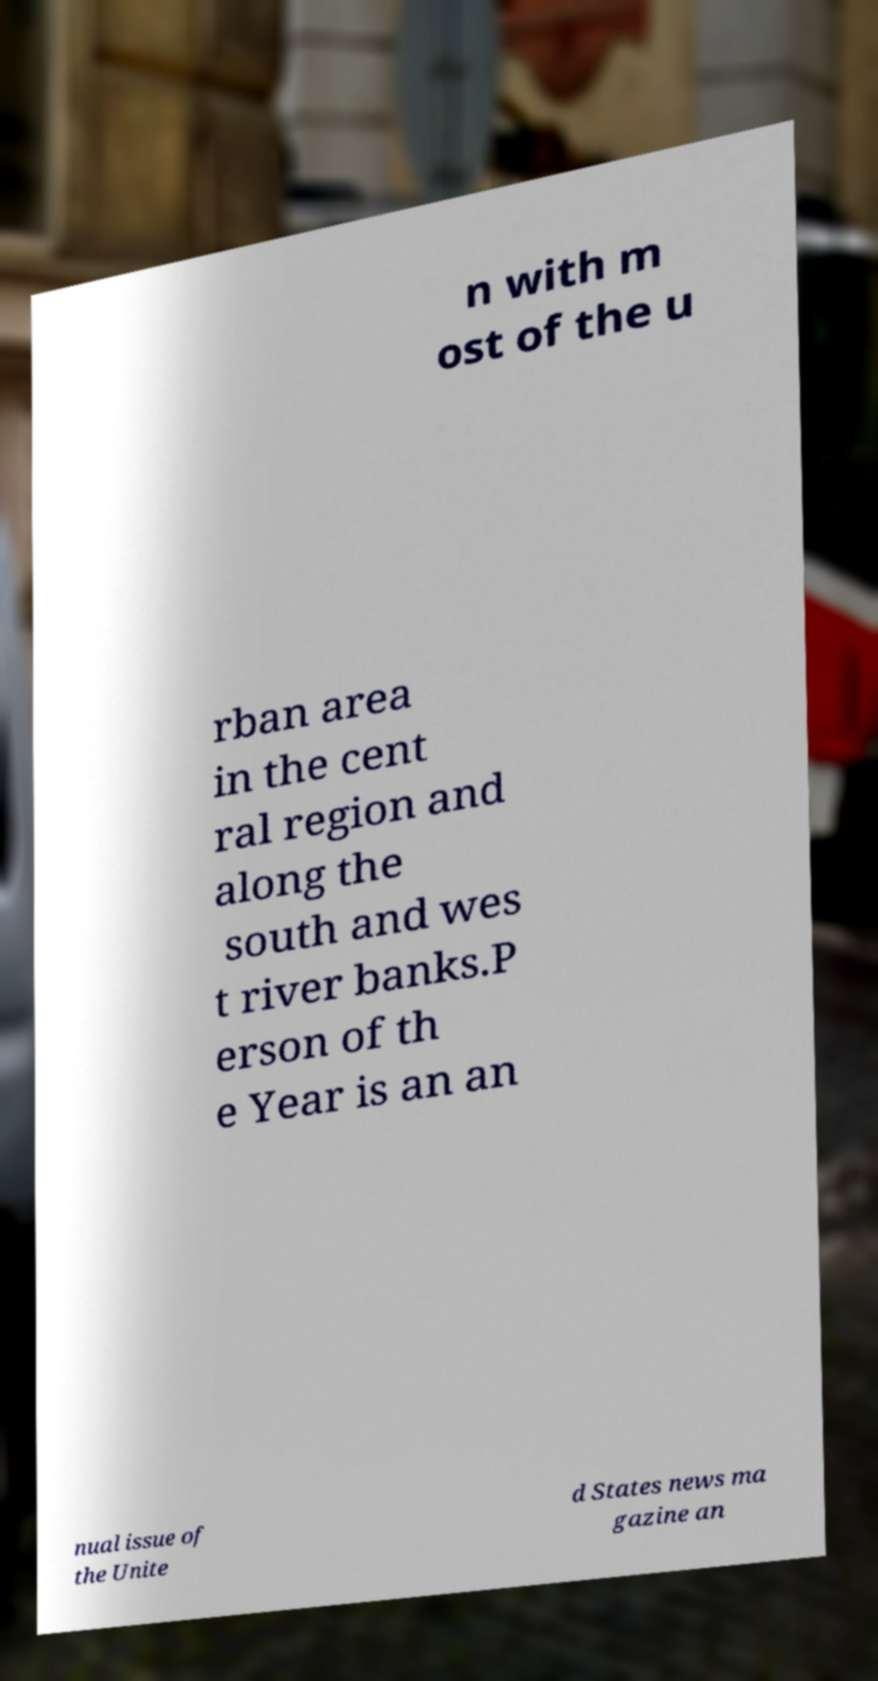Please read and relay the text visible in this image. What does it say? n with m ost of the u rban area in the cent ral region and along the south and wes t river banks.P erson of th e Year is an an nual issue of the Unite d States news ma gazine an 